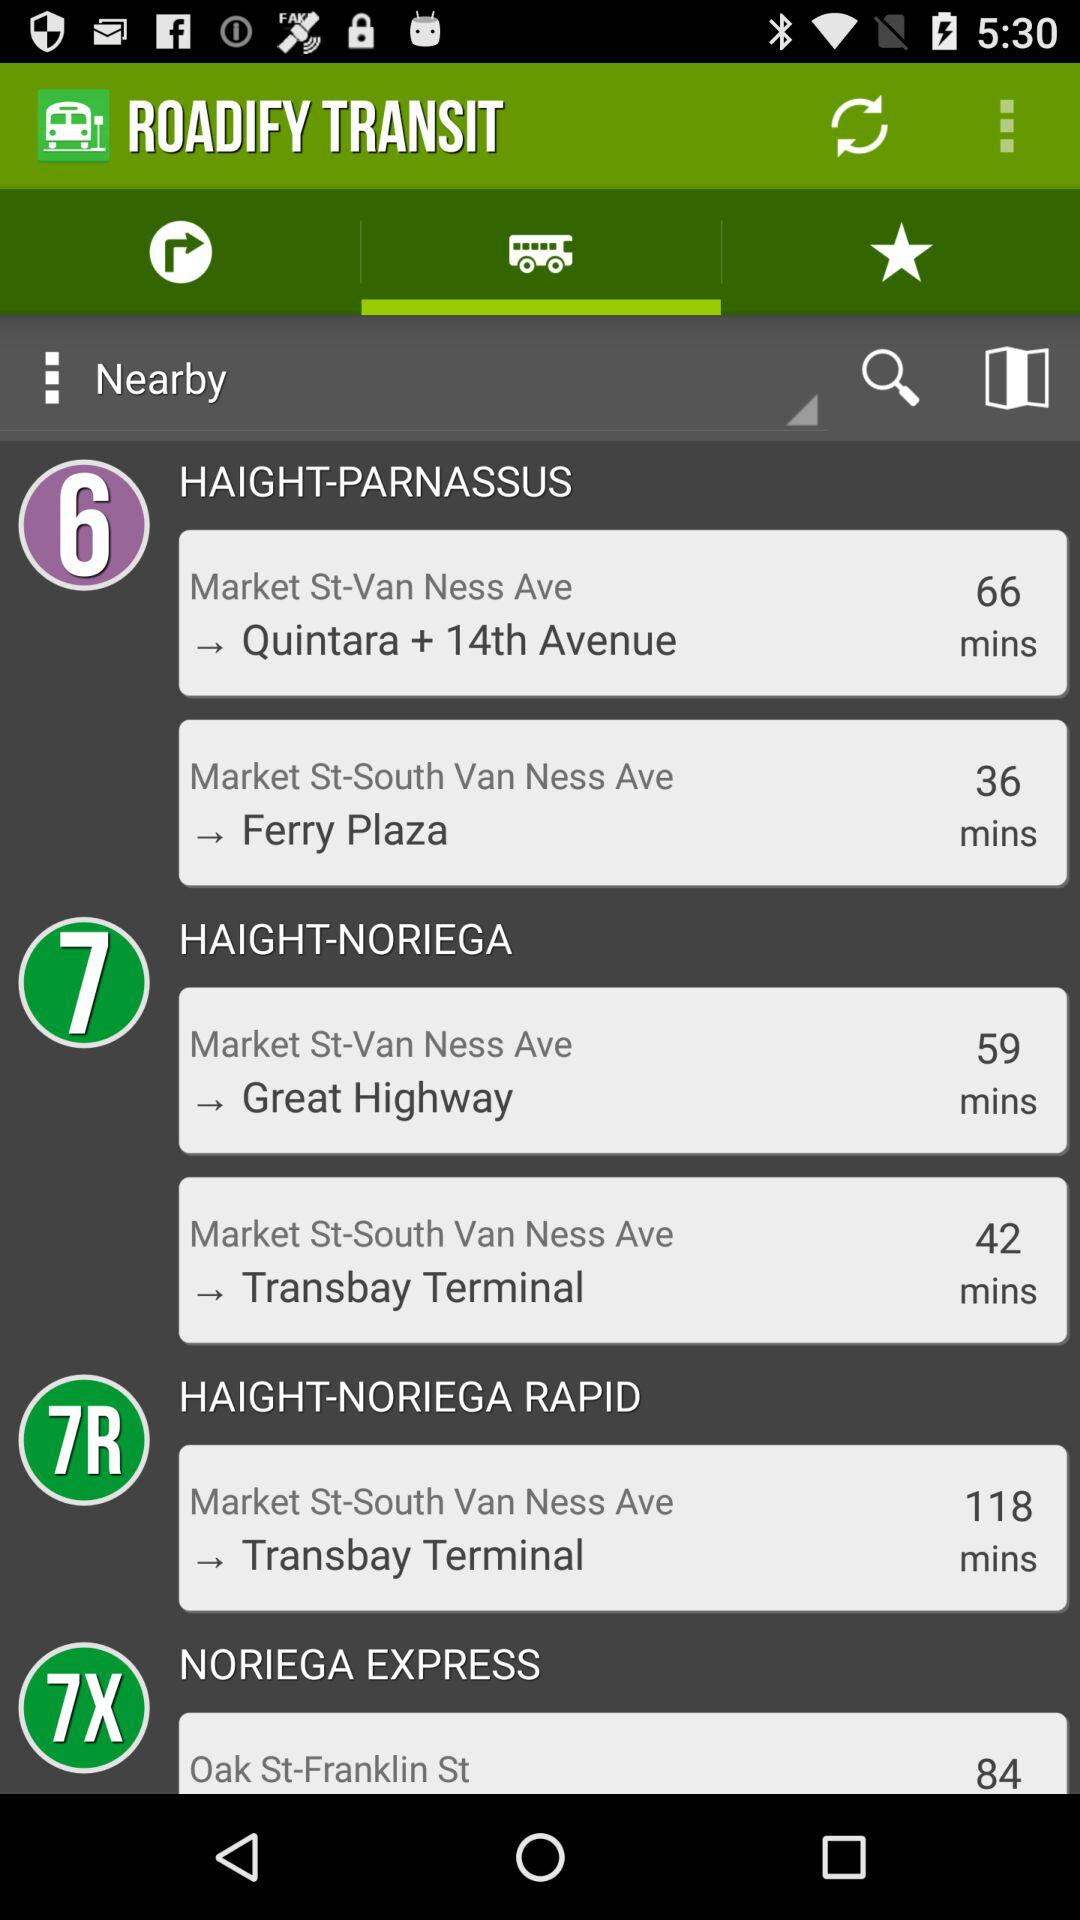How many lines are available?
Answer the question using a single word or phrase. 6 